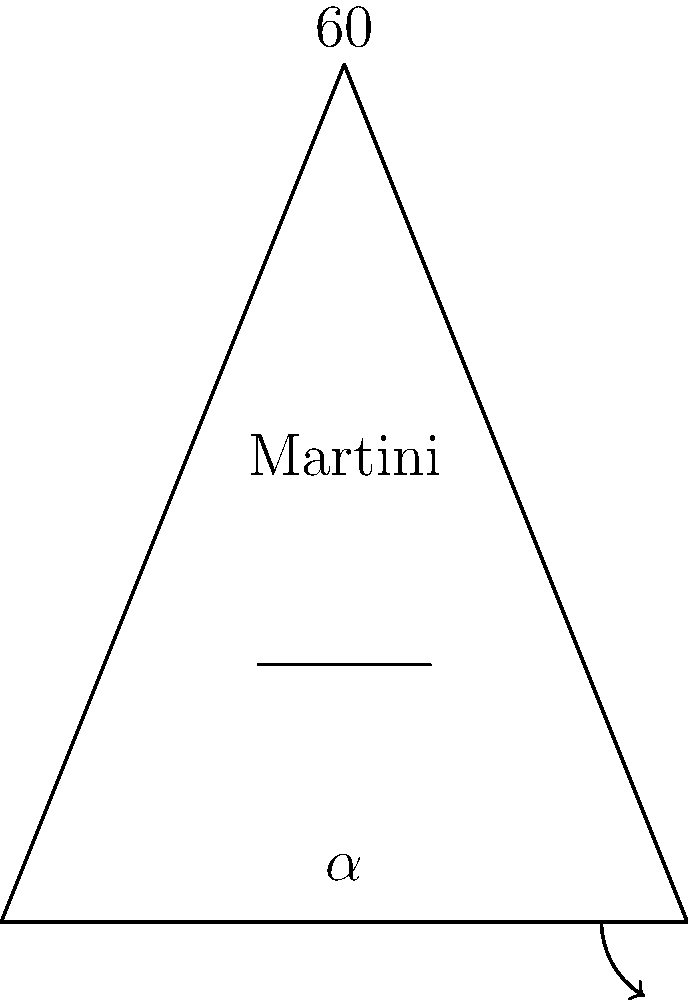In your signature martini glass design, the rim angle is 60°. If the stem angle (labeled $\alpha$ in the diagram) is half the rim angle, what is the measure of the stem angle? How might this angle affect the presentation and stability of the cocktail? Let's approach this step-by-step:

1) We are given that the rim angle of the martini glass is 60°.

2) The question states that the stem angle ($\alpha$) is half the rim angle.

3) To find the stem angle, we can set up the following equation:
   $$\alpha = \frac{1}{2} \times 60°$$

4) Solving for $\alpha$:
   $$\alpha = 30°$$

5) Regarding the presentation and stability:
   - A 30° stem angle creates a wider base, increasing stability and reducing the likelihood of spills.
   - This angle also affects the surface area of the cocktail exposed to air, which can influence the rate of temperature change and the release of aromatic compounds.
   - The wider base and narrower top accentuate the cocktail's color and any garnishes, enhancing visual appeal.
   - The 30° angle allows for a comfortable grip on the stem while maintaining the cocktail's temperature.
Answer: 30° 